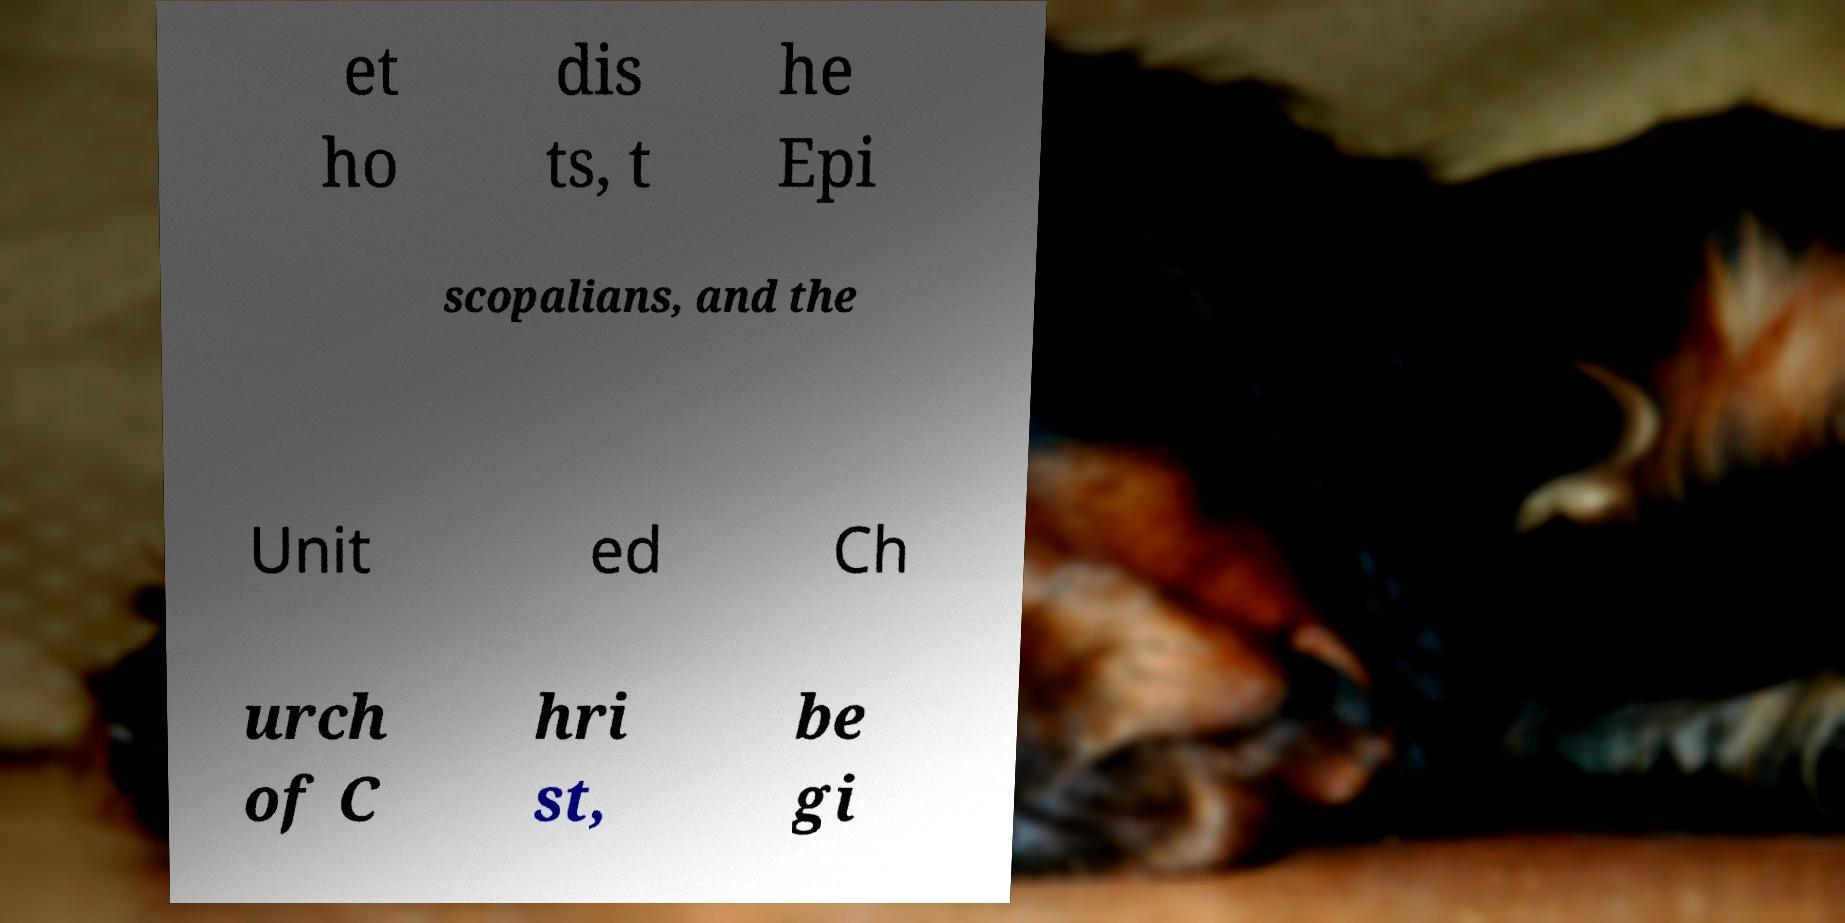Please identify and transcribe the text found in this image. et ho dis ts, t he Epi scopalians, and the Unit ed Ch urch of C hri st, be gi 